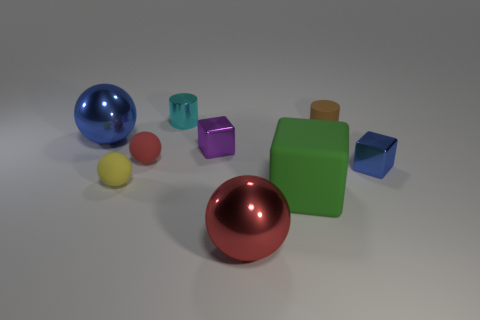Are there more small brown cylinders behind the brown cylinder than green rubber things?
Give a very brief answer. No. How many objects are either tiny metal cubes behind the small red rubber ball or metallic things that are behind the green matte block?
Offer a terse response. 4. There is a blue ball that is made of the same material as the small blue thing; what size is it?
Provide a short and direct response. Large. There is a tiny object behind the small brown rubber cylinder; is it the same shape as the big red object?
Offer a terse response. No. How many cyan things are either big rubber cylinders or large blocks?
Ensure brevity in your answer.  0. What number of other objects are the same shape as the tiny blue metallic thing?
Provide a short and direct response. 2. What shape is the small shiny thing that is both in front of the brown thing and behind the red rubber thing?
Your response must be concise. Cube. Are there any small purple metallic cubes behind the blue sphere?
Ensure brevity in your answer.  No. There is a purple metal thing that is the same shape as the green object; what size is it?
Provide a succinct answer. Small. Are there any other things that have the same size as the brown matte cylinder?
Make the answer very short. Yes. 